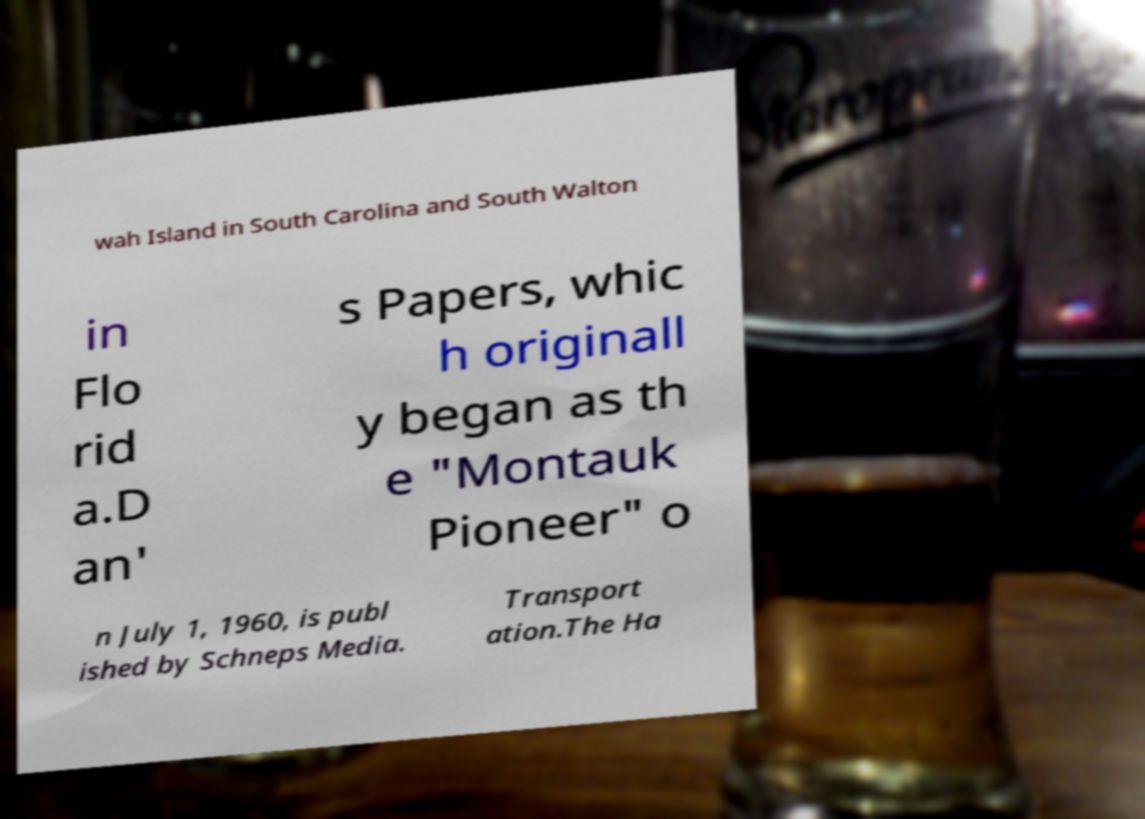Please read and relay the text visible in this image. What does it say? wah Island in South Carolina and South Walton in Flo rid a.D an' s Papers, whic h originall y began as th e "Montauk Pioneer" o n July 1, 1960, is publ ished by Schneps Media. Transport ation.The Ha 